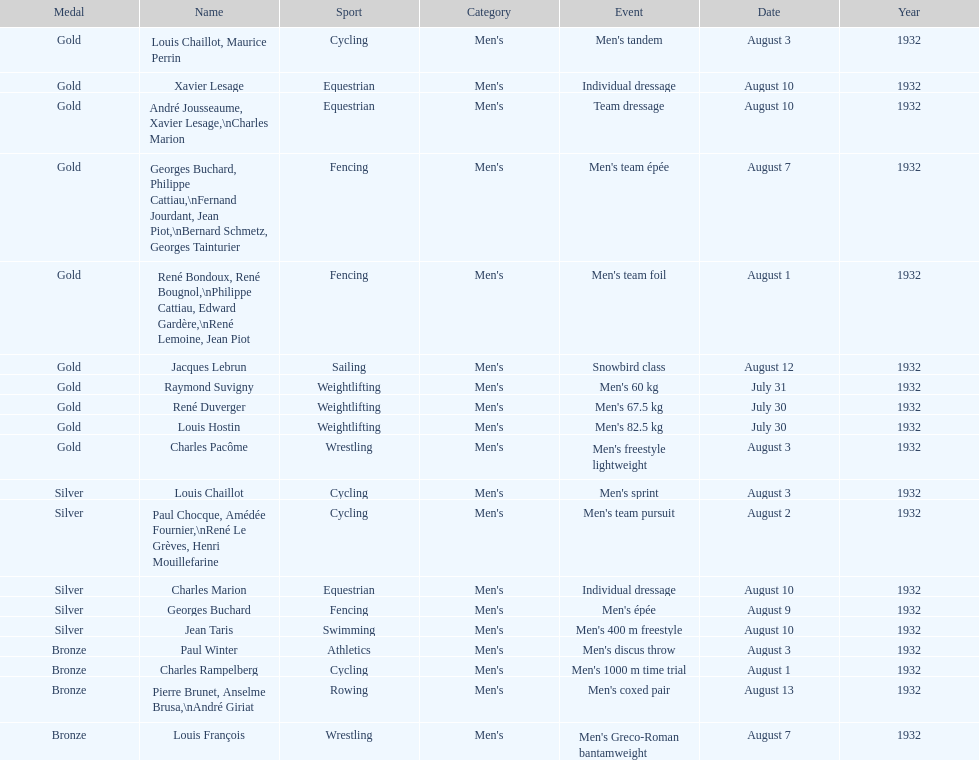What is next date that is listed after august 7th? August 1. 